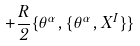Convert formula to latex. <formula><loc_0><loc_0><loc_500><loc_500>+ \frac { R } { 2 } \{ \theta ^ { \alpha } , \{ \theta ^ { \alpha } , X ^ { I } \} \}</formula> 